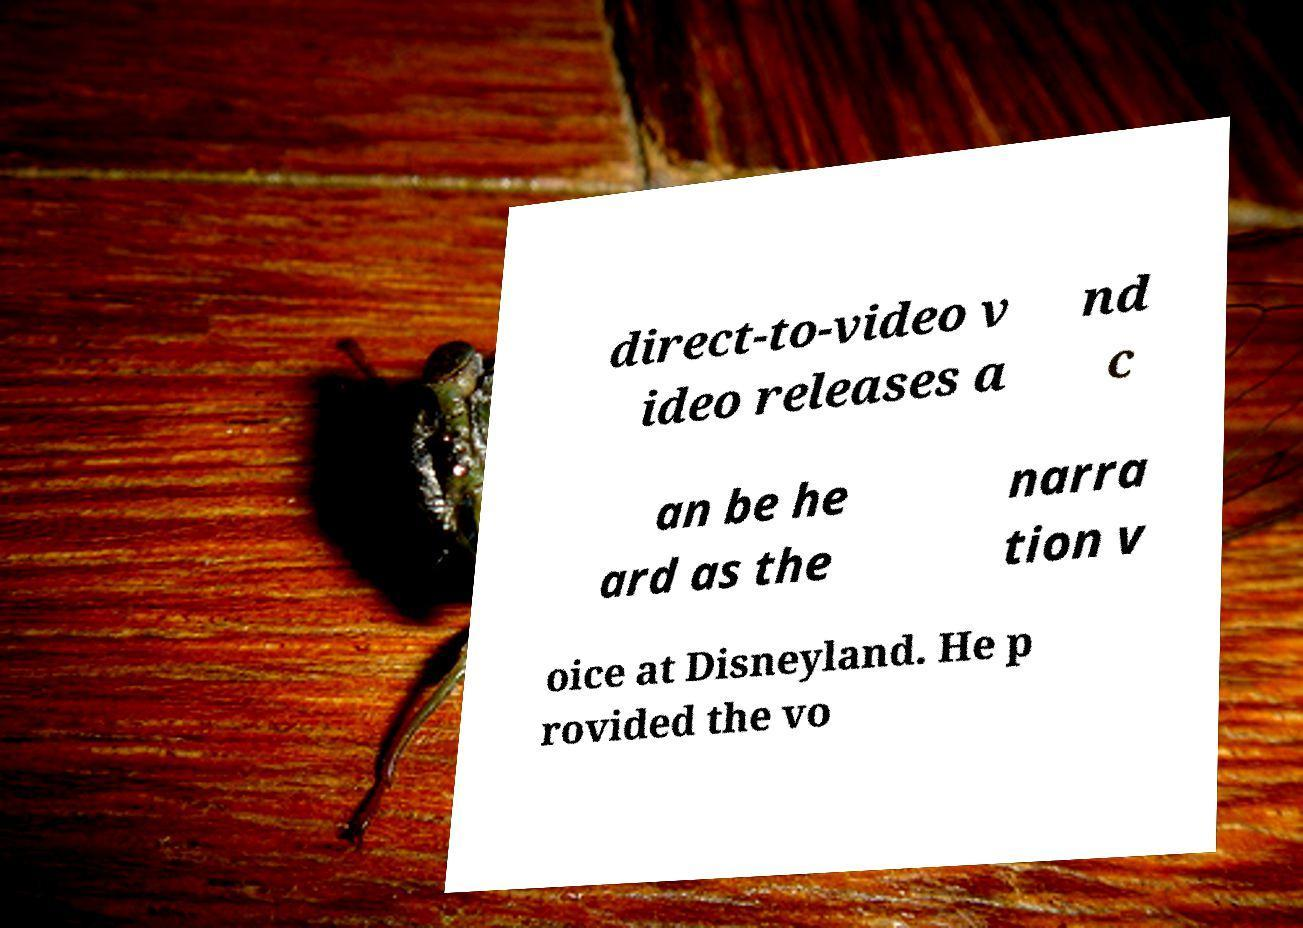I need the written content from this picture converted into text. Can you do that? direct-to-video v ideo releases a nd c an be he ard as the narra tion v oice at Disneyland. He p rovided the vo 